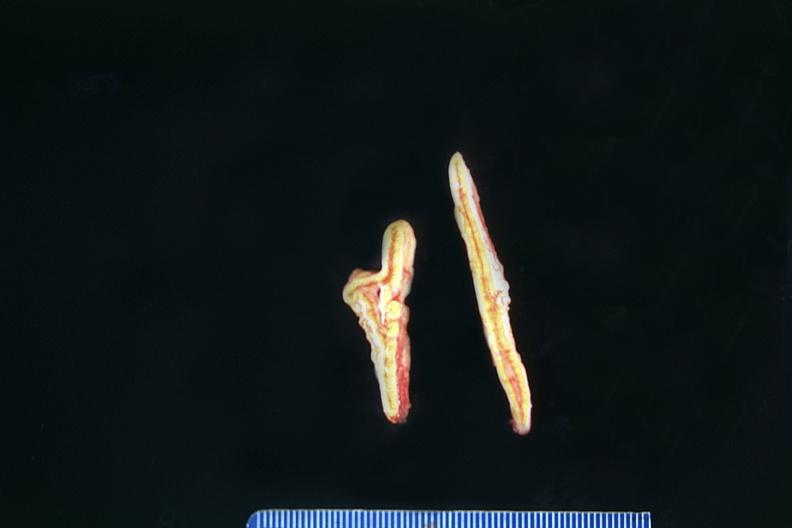where does this belong to?
Answer the question using a single word or phrase. Endocrine system 